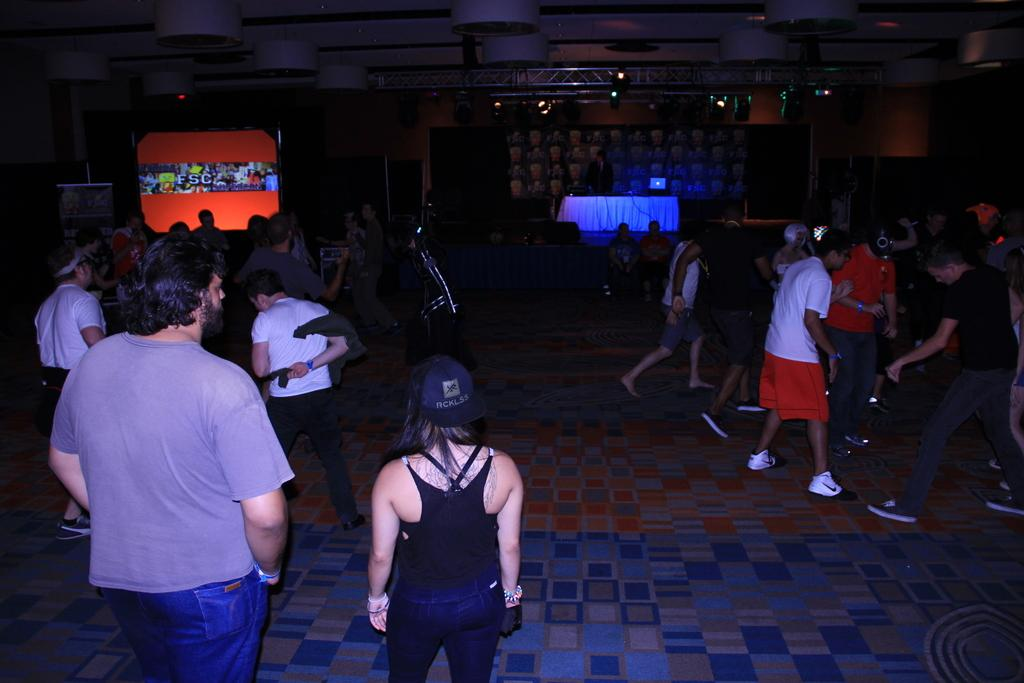How many people are in the group that is visible in the image? There is a group of people standing in the image, but the exact number cannot be determined from the provided facts. What can be seen on the table in the image? There are objects on a table in the image, but the specific objects are not mentioned in the provided facts. What is the purpose of the screen in the image? The purpose of the screen in the image cannot be determined from the provided facts. What message or information is conveyed by the banner in the image? The message or information on the banner in the image cannot be determined from the provided facts. What type of lighting is being used in the image? There is a lighting truss with focus lights in the image. What type of frame is being used to hold the flag in the image? There is no flag present in the image, so there is no frame being used to hold it. 